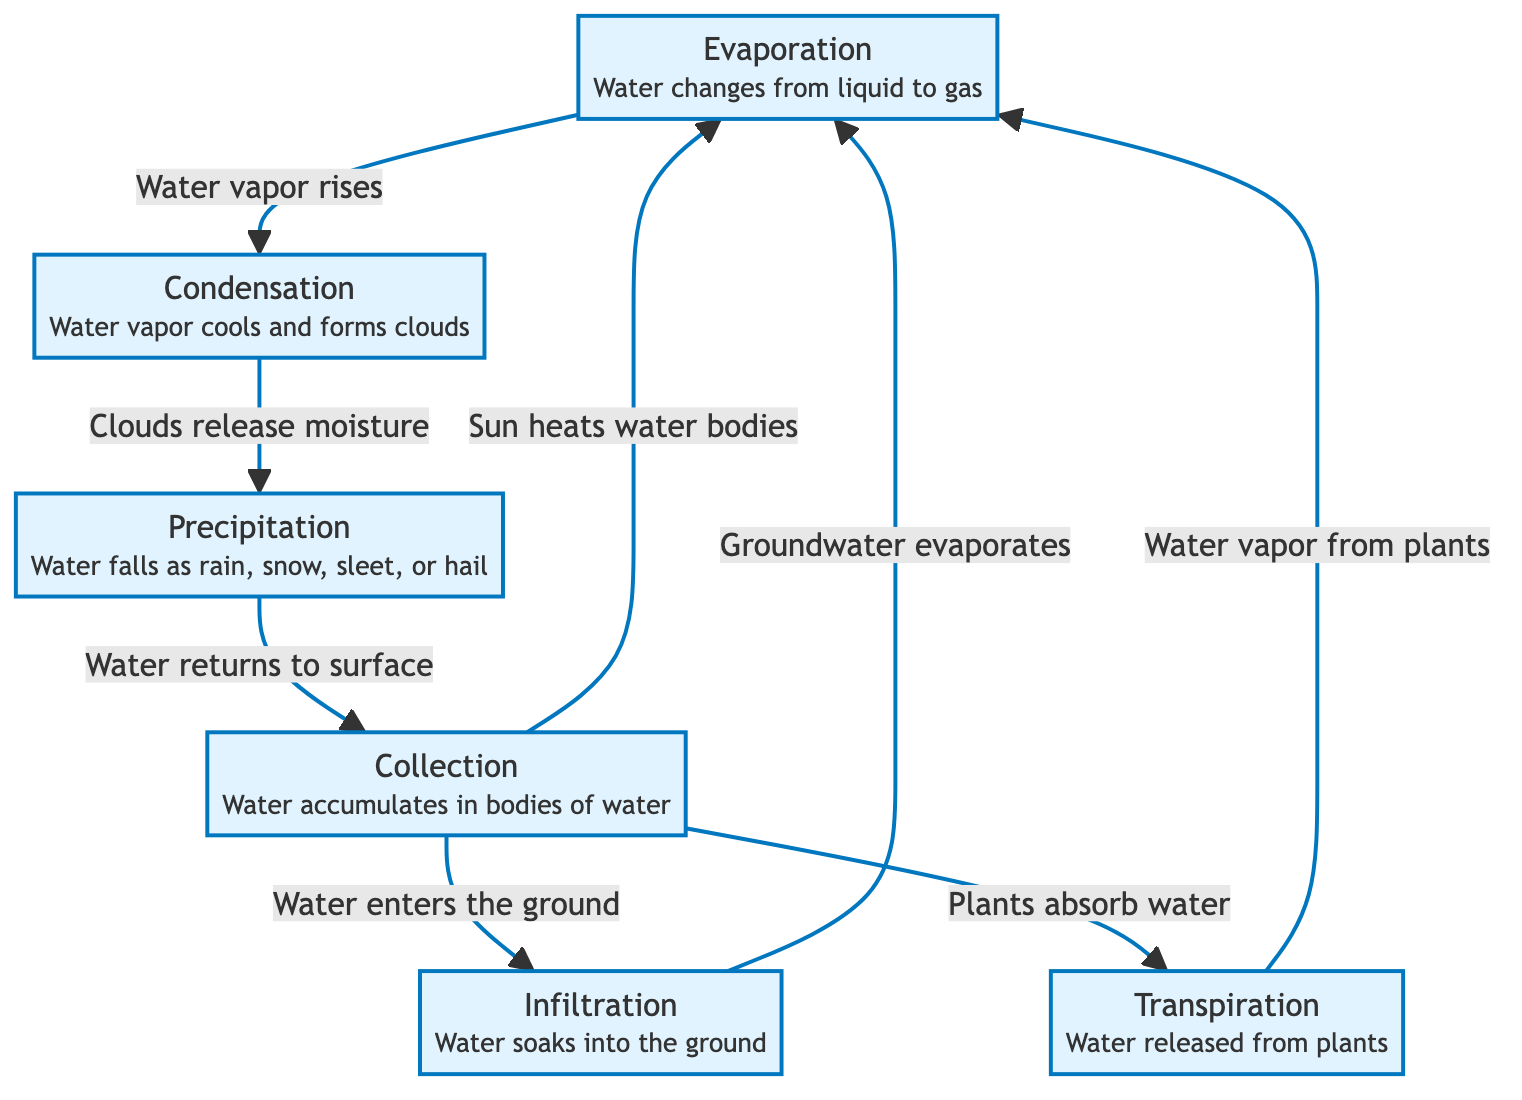What is the first process in the water cycle? The diagram shows that evaporation is the first process as it is positioned at the beginning of the flow.
Answer: Evaporation How many main processes are represented in the diagram? By counting the distinct processes shown (evaporation, condensation, precipitation, collection, infiltration, transpiration), we find there are six main processes.
Answer: Six What happens after condensation? According to the diagram, after condensation, the next process is precipitation, indicating that water vapor cools and forms clouds before releasing moisture.
Answer: Precipitation Which process returns water to the surface? The diagram clearly states that precipitation is the process where water falls back to the Earth's surface from the clouds.
Answer: Precipitation What process involves water soaking into the ground? Infiltration is specifically mentioned as the process where water soaks into the ground after precipitation.
Answer: Infiltration How does transpiration contribute to evaporation? The diagram illustrates that transpiration involves water being released from plants, which then leads to evaporation as water vapor rises into the atmosphere.
Answer: Water vapor from plants What process follows collection in the water cycle? Following the collection of water in bodies, the diagram indicates that evaporation occurs next, as the sun heats the water bodies causing evaporation to happen.
Answer: Evaporation What is the relationship between collection and infiltration? The diagram indicates that water enters the ground through infiltration, which is a process that can occur after collection, showing a direct flow from collection to infiltration.
Answer: Water enters the ground What role does sunlight play in the water cycle according to the diagram? The diagram explains that the sun heats water bodies, which leads to the evaporation process, showing the influence of sunlight in initiating evaporation.
Answer: Heats water bodies 